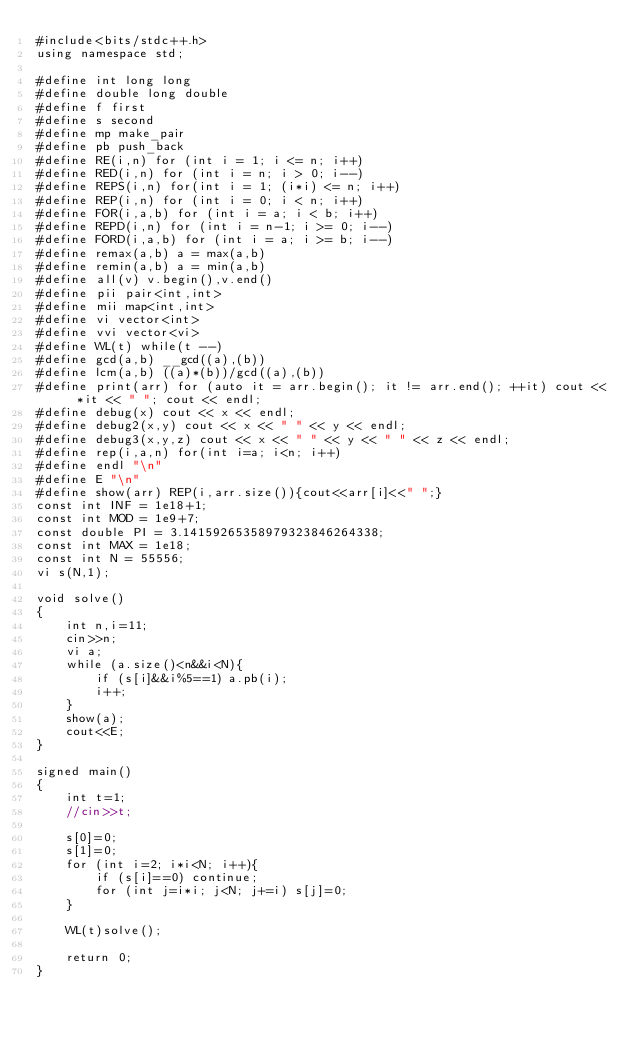Convert code to text. <code><loc_0><loc_0><loc_500><loc_500><_C++_>#include<bits/stdc++.h>
using namespace std;

#define int long long
#define double long double
#define f first
#define s second
#define mp make_pair
#define pb push_back
#define RE(i,n) for (int i = 1; i <= n; i++)
#define RED(i,n) for (int i = n; i > 0; i--)
#define REPS(i,n) for(int i = 1; (i*i) <= n; i++)
#define REP(i,n) for (int i = 0; i < n; i++)
#define FOR(i,a,b) for (int i = a; i < b; i++)
#define REPD(i,n) for (int i = n-1; i >= 0; i--)
#define FORD(i,a,b) for (int i = a; i >= b; i--)
#define remax(a,b) a = max(a,b)
#define remin(a,b) a = min(a,b)
#define all(v) v.begin(),v.end()
#define pii pair<int,int>
#define mii map<int,int>
#define vi vector<int>
#define vvi vector<vi>
#define WL(t) while(t --)
#define gcd(a,b) __gcd((a),(b))
#define lcm(a,b) ((a)*(b))/gcd((a),(b))
#define print(arr) for (auto it = arr.begin(); it != arr.end(); ++it) cout << *it << " "; cout << endl;
#define debug(x) cout << x << endl;
#define debug2(x,y) cout << x << " " << y << endl;
#define debug3(x,y,z) cout << x << " " << y << " " << z << endl;
#define rep(i,a,n) for(int i=a; i<n; i++)
#define endl "\n"
#define E "\n"
#define show(arr) REP(i,arr.size()){cout<<arr[i]<<" ";}
const int INF = 1e18+1;
const int MOD = 1e9+7;
const double PI = 3.14159265358979323846264338;
const int MAX = 1e18;
const int N = 55556;
vi s(N,1);

void solve()
{
    int n,i=11;
    cin>>n;
    vi a;
    while (a.size()<n&&i<N){
        if (s[i]&&i%5==1) a.pb(i);
        i++;
    }
    show(a);
    cout<<E;
}

signed main()
{
    int t=1;
    //cin>>t;

    s[0]=0;
    s[1]=0;
    for (int i=2; i*i<N; i++){
        if (s[i]==0) continue;
        for (int j=i*i; j<N; j+=i) s[j]=0;
    }

    WL(t)solve();

    return 0;
}
</code> 